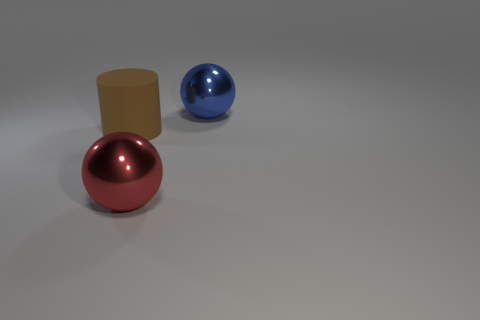Subtract all cylinders. How many objects are left? 2 Add 2 blue things. How many objects exist? 5 Subtract all red balls. How many balls are left? 1 Subtract 1 balls. How many balls are left? 1 Subtract all blue spheres. Subtract all red blocks. How many spheres are left? 1 Subtract all green blocks. How many blue spheres are left? 1 Subtract all small green metallic things. Subtract all red balls. How many objects are left? 2 Add 2 brown things. How many brown things are left? 3 Add 1 brown cylinders. How many brown cylinders exist? 2 Subtract 0 blue cylinders. How many objects are left? 3 